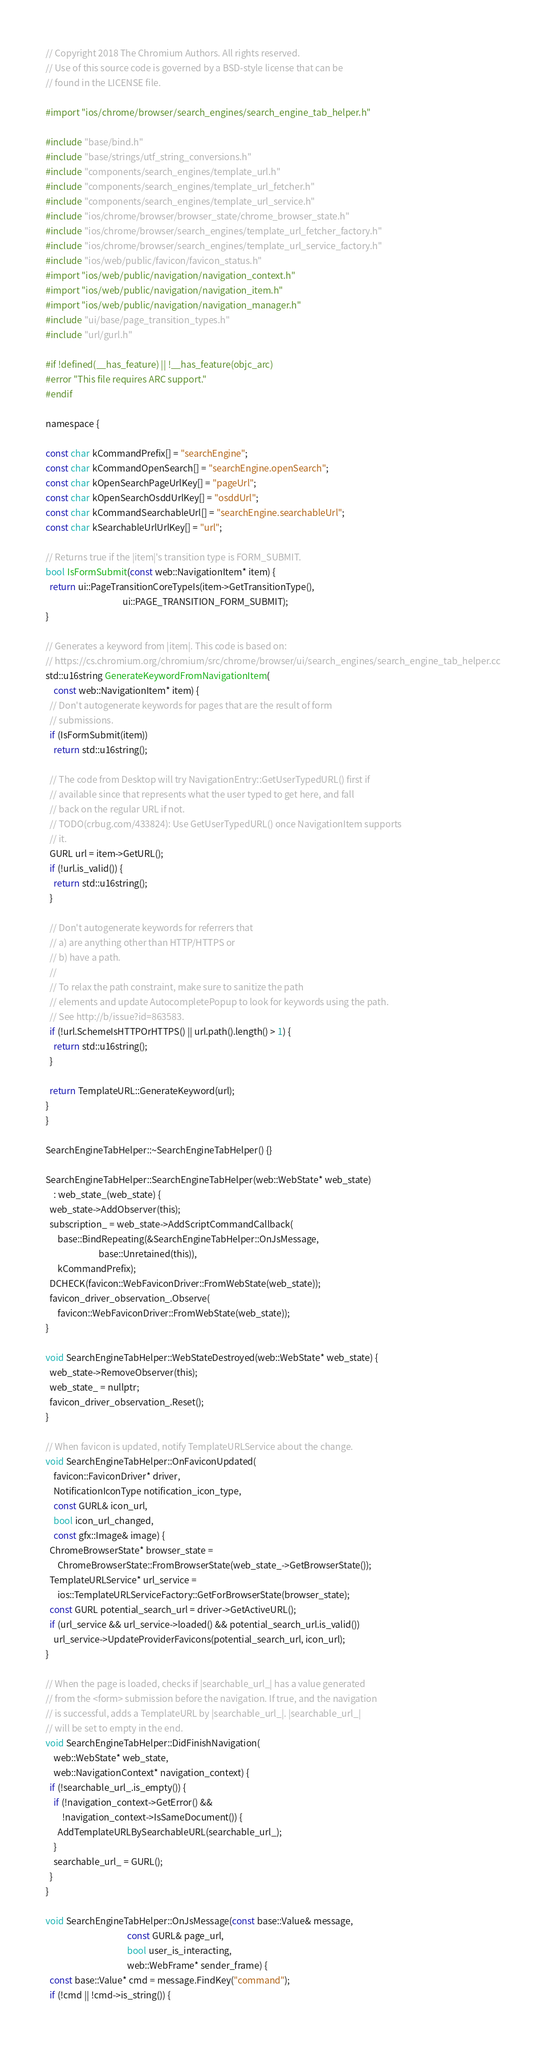Convert code to text. <code><loc_0><loc_0><loc_500><loc_500><_ObjectiveC_>// Copyright 2018 The Chromium Authors. All rights reserved.
// Use of this source code is governed by a BSD-style license that can be
// found in the LICENSE file.

#import "ios/chrome/browser/search_engines/search_engine_tab_helper.h"

#include "base/bind.h"
#include "base/strings/utf_string_conversions.h"
#include "components/search_engines/template_url.h"
#include "components/search_engines/template_url_fetcher.h"
#include "components/search_engines/template_url_service.h"
#include "ios/chrome/browser/browser_state/chrome_browser_state.h"
#include "ios/chrome/browser/search_engines/template_url_fetcher_factory.h"
#include "ios/chrome/browser/search_engines/template_url_service_factory.h"
#include "ios/web/public/favicon/favicon_status.h"
#import "ios/web/public/navigation/navigation_context.h"
#import "ios/web/public/navigation/navigation_item.h"
#import "ios/web/public/navigation/navigation_manager.h"
#include "ui/base/page_transition_types.h"
#include "url/gurl.h"

#if !defined(__has_feature) || !__has_feature(objc_arc)
#error "This file requires ARC support."
#endif

namespace {

const char kCommandPrefix[] = "searchEngine";
const char kCommandOpenSearch[] = "searchEngine.openSearch";
const char kOpenSearchPageUrlKey[] = "pageUrl";
const char kOpenSearchOsddUrlKey[] = "osddUrl";
const char kCommandSearchableUrl[] = "searchEngine.searchableUrl";
const char kSearchableUrlUrlKey[] = "url";

// Returns true if the |item|'s transition type is FORM_SUBMIT.
bool IsFormSubmit(const web::NavigationItem* item) {
  return ui::PageTransitionCoreTypeIs(item->GetTransitionType(),
                                      ui::PAGE_TRANSITION_FORM_SUBMIT);
}

// Generates a keyword from |item|. This code is based on:
// https://cs.chromium.org/chromium/src/chrome/browser/ui/search_engines/search_engine_tab_helper.cc
std::u16string GenerateKeywordFromNavigationItem(
    const web::NavigationItem* item) {
  // Don't autogenerate keywords for pages that are the result of form
  // submissions.
  if (IsFormSubmit(item))
    return std::u16string();

  // The code from Desktop will try NavigationEntry::GetUserTypedURL() first if
  // available since that represents what the user typed to get here, and fall
  // back on the regular URL if not.
  // TODO(crbug.com/433824): Use GetUserTypedURL() once NavigationItem supports
  // it.
  GURL url = item->GetURL();
  if (!url.is_valid()) {
    return std::u16string();
  }

  // Don't autogenerate keywords for referrers that
  // a) are anything other than HTTP/HTTPS or
  // b) have a path.
  //
  // To relax the path constraint, make sure to sanitize the path
  // elements and update AutocompletePopup to look for keywords using the path.
  // See http://b/issue?id=863583.
  if (!url.SchemeIsHTTPOrHTTPS() || url.path().length() > 1) {
    return std::u16string();
  }

  return TemplateURL::GenerateKeyword(url);
}
}

SearchEngineTabHelper::~SearchEngineTabHelper() {}

SearchEngineTabHelper::SearchEngineTabHelper(web::WebState* web_state)
    : web_state_(web_state) {
  web_state->AddObserver(this);
  subscription_ = web_state->AddScriptCommandCallback(
      base::BindRepeating(&SearchEngineTabHelper::OnJsMessage,
                          base::Unretained(this)),
      kCommandPrefix);
  DCHECK(favicon::WebFaviconDriver::FromWebState(web_state));
  favicon_driver_observation_.Observe(
      favicon::WebFaviconDriver::FromWebState(web_state));
}

void SearchEngineTabHelper::WebStateDestroyed(web::WebState* web_state) {
  web_state->RemoveObserver(this);
  web_state_ = nullptr;
  favicon_driver_observation_.Reset();
}

// When favicon is updated, notify TemplateURLService about the change.
void SearchEngineTabHelper::OnFaviconUpdated(
    favicon::FaviconDriver* driver,
    NotificationIconType notification_icon_type,
    const GURL& icon_url,
    bool icon_url_changed,
    const gfx::Image& image) {
  ChromeBrowserState* browser_state =
      ChromeBrowserState::FromBrowserState(web_state_->GetBrowserState());
  TemplateURLService* url_service =
      ios::TemplateURLServiceFactory::GetForBrowserState(browser_state);
  const GURL potential_search_url = driver->GetActiveURL();
  if (url_service && url_service->loaded() && potential_search_url.is_valid())
    url_service->UpdateProviderFavicons(potential_search_url, icon_url);
}

// When the page is loaded, checks if |searchable_url_| has a value generated
// from the <form> submission before the navigation. If true, and the navigation
// is successful, adds a TemplateURL by |searchable_url_|. |searchable_url_|
// will be set to empty in the end.
void SearchEngineTabHelper::DidFinishNavigation(
    web::WebState* web_state,
    web::NavigationContext* navigation_context) {
  if (!searchable_url_.is_empty()) {
    if (!navigation_context->GetError() &&
        !navigation_context->IsSameDocument()) {
      AddTemplateURLBySearchableURL(searchable_url_);
    }
    searchable_url_ = GURL();
  }
}

void SearchEngineTabHelper::OnJsMessage(const base::Value& message,
                                        const GURL& page_url,
                                        bool user_is_interacting,
                                        web::WebFrame* sender_frame) {
  const base::Value* cmd = message.FindKey("command");
  if (!cmd || !cmd->is_string()) {</code> 